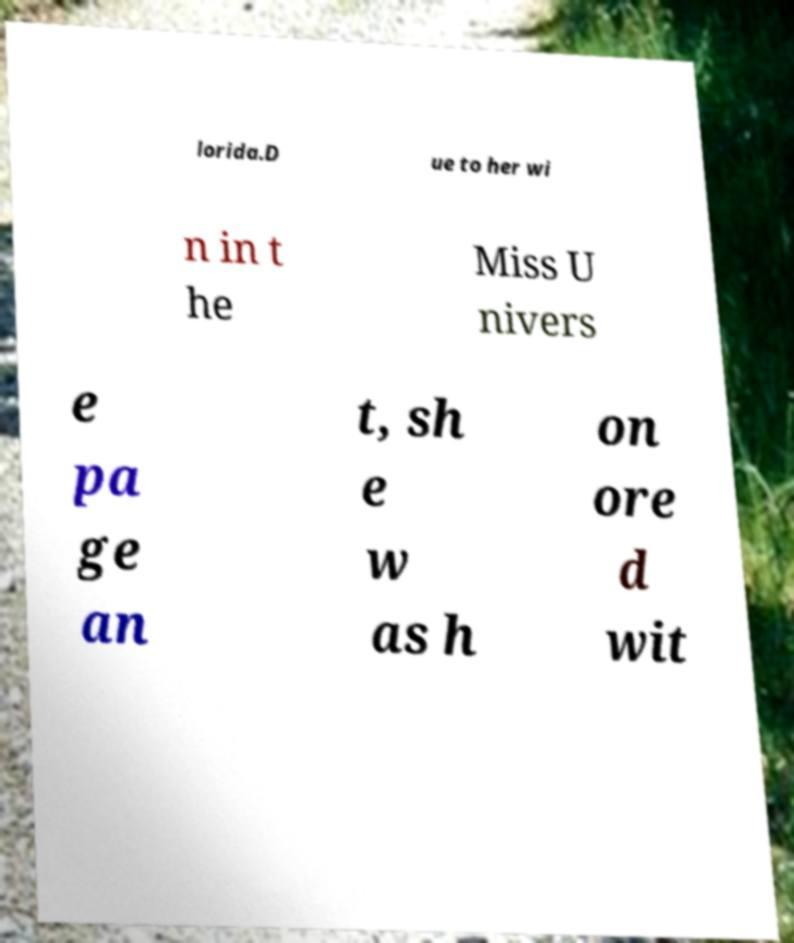Can you read and provide the text displayed in the image?This photo seems to have some interesting text. Can you extract and type it out for me? lorida.D ue to her wi n in t he Miss U nivers e pa ge an t, sh e w as h on ore d wit 